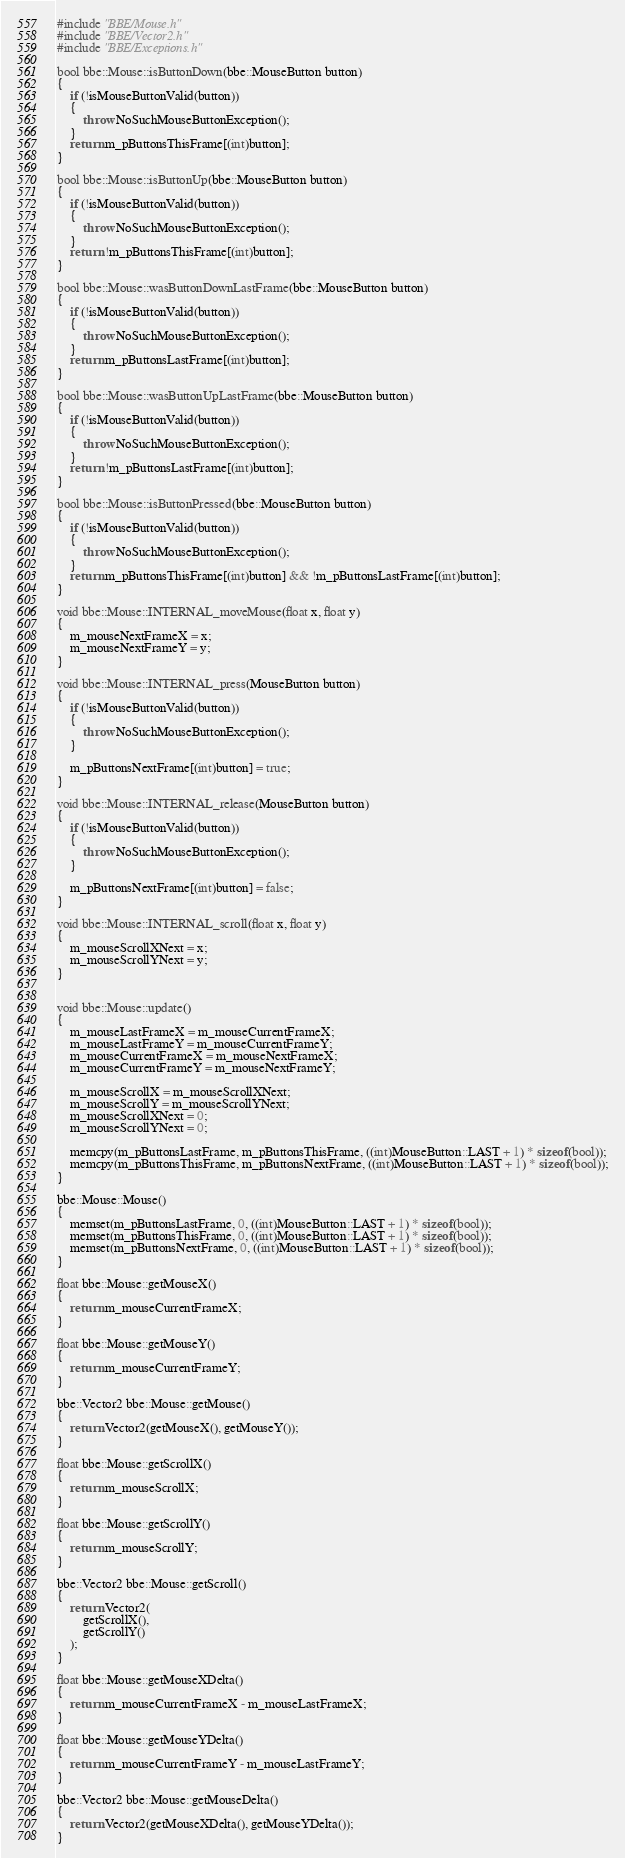<code> <loc_0><loc_0><loc_500><loc_500><_C++_>#include "BBE/Mouse.h"
#include "BBE/Vector2.h"
#include "BBE/Exceptions.h"

bool bbe::Mouse::isButtonDown(bbe::MouseButton button)
{
	if (!isMouseButtonValid(button))
	{
		throw NoSuchMouseButtonException();
	}
	return m_pButtonsThisFrame[(int)button];
}

bool bbe::Mouse::isButtonUp(bbe::MouseButton button)
{
	if (!isMouseButtonValid(button))
	{
		throw NoSuchMouseButtonException();
	}
	return !m_pButtonsThisFrame[(int)button];
}

bool bbe::Mouse::wasButtonDownLastFrame(bbe::MouseButton button)
{
	if (!isMouseButtonValid(button))
	{
		throw NoSuchMouseButtonException();
	}
	return m_pButtonsLastFrame[(int)button];
}

bool bbe::Mouse::wasButtonUpLastFrame(bbe::MouseButton button)
{
	if (!isMouseButtonValid(button))
	{
		throw NoSuchMouseButtonException();
	}
	return !m_pButtonsLastFrame[(int)button];
}

bool bbe::Mouse::isButtonPressed(bbe::MouseButton button)
{
	if (!isMouseButtonValid(button))
	{
		throw NoSuchMouseButtonException();
	}
	return m_pButtonsThisFrame[(int)button] && !m_pButtonsLastFrame[(int)button];
}

void bbe::Mouse::INTERNAL_moveMouse(float x, float y)
{
	m_mouseNextFrameX = x;
	m_mouseNextFrameY = y;
}

void bbe::Mouse::INTERNAL_press(MouseButton button)
{
	if (!isMouseButtonValid(button))
	{
		throw NoSuchMouseButtonException();
	}

	m_pButtonsNextFrame[(int)button] = true;
}

void bbe::Mouse::INTERNAL_release(MouseButton button)
{
	if (!isMouseButtonValid(button))
	{
		throw NoSuchMouseButtonException();
	}

	m_pButtonsNextFrame[(int)button] = false;
}

void bbe::Mouse::INTERNAL_scroll(float x, float y)
{
	m_mouseScrollXNext = x;
	m_mouseScrollYNext = y;
}


void bbe::Mouse::update()
{
	m_mouseLastFrameX = m_mouseCurrentFrameX;
	m_mouseLastFrameY = m_mouseCurrentFrameY;
	m_mouseCurrentFrameX = m_mouseNextFrameX;
	m_mouseCurrentFrameY = m_mouseNextFrameY;

	m_mouseScrollX = m_mouseScrollXNext;
	m_mouseScrollY = m_mouseScrollYNext;
	m_mouseScrollXNext = 0;
	m_mouseScrollYNext = 0;

	memcpy(m_pButtonsLastFrame, m_pButtonsThisFrame, ((int)MouseButton::LAST + 1) * sizeof(bool));
	memcpy(m_pButtonsThisFrame, m_pButtonsNextFrame, ((int)MouseButton::LAST + 1) * sizeof(bool));
}

bbe::Mouse::Mouse()
{
	memset(m_pButtonsLastFrame, 0, ((int)MouseButton::LAST + 1) * sizeof(bool));
	memset(m_pButtonsThisFrame, 0, ((int)MouseButton::LAST + 1) * sizeof(bool));
	memset(m_pButtonsNextFrame, 0, ((int)MouseButton::LAST + 1) * sizeof(bool));
}

float bbe::Mouse::getMouseX()
{
	return m_mouseCurrentFrameX;
}

float bbe::Mouse::getMouseY()
{
	return m_mouseCurrentFrameY;
}

bbe::Vector2 bbe::Mouse::getMouse()
{
	return Vector2(getMouseX(), getMouseY());
}

float bbe::Mouse::getScrollX()
{
	return m_mouseScrollX;
}

float bbe::Mouse::getScrollY()
{
	return m_mouseScrollY;
}

bbe::Vector2 bbe::Mouse::getScroll()
{
	return Vector2(
		getScrollX(),
		getScrollY()
	);
}

float bbe::Mouse::getMouseXDelta()
{
	return m_mouseCurrentFrameX - m_mouseLastFrameX;
}

float bbe::Mouse::getMouseYDelta()
{
	return m_mouseCurrentFrameY - m_mouseLastFrameY;
}

bbe::Vector2 bbe::Mouse::getMouseDelta()
{
	return Vector2(getMouseXDelta(), getMouseYDelta());
}
</code> 